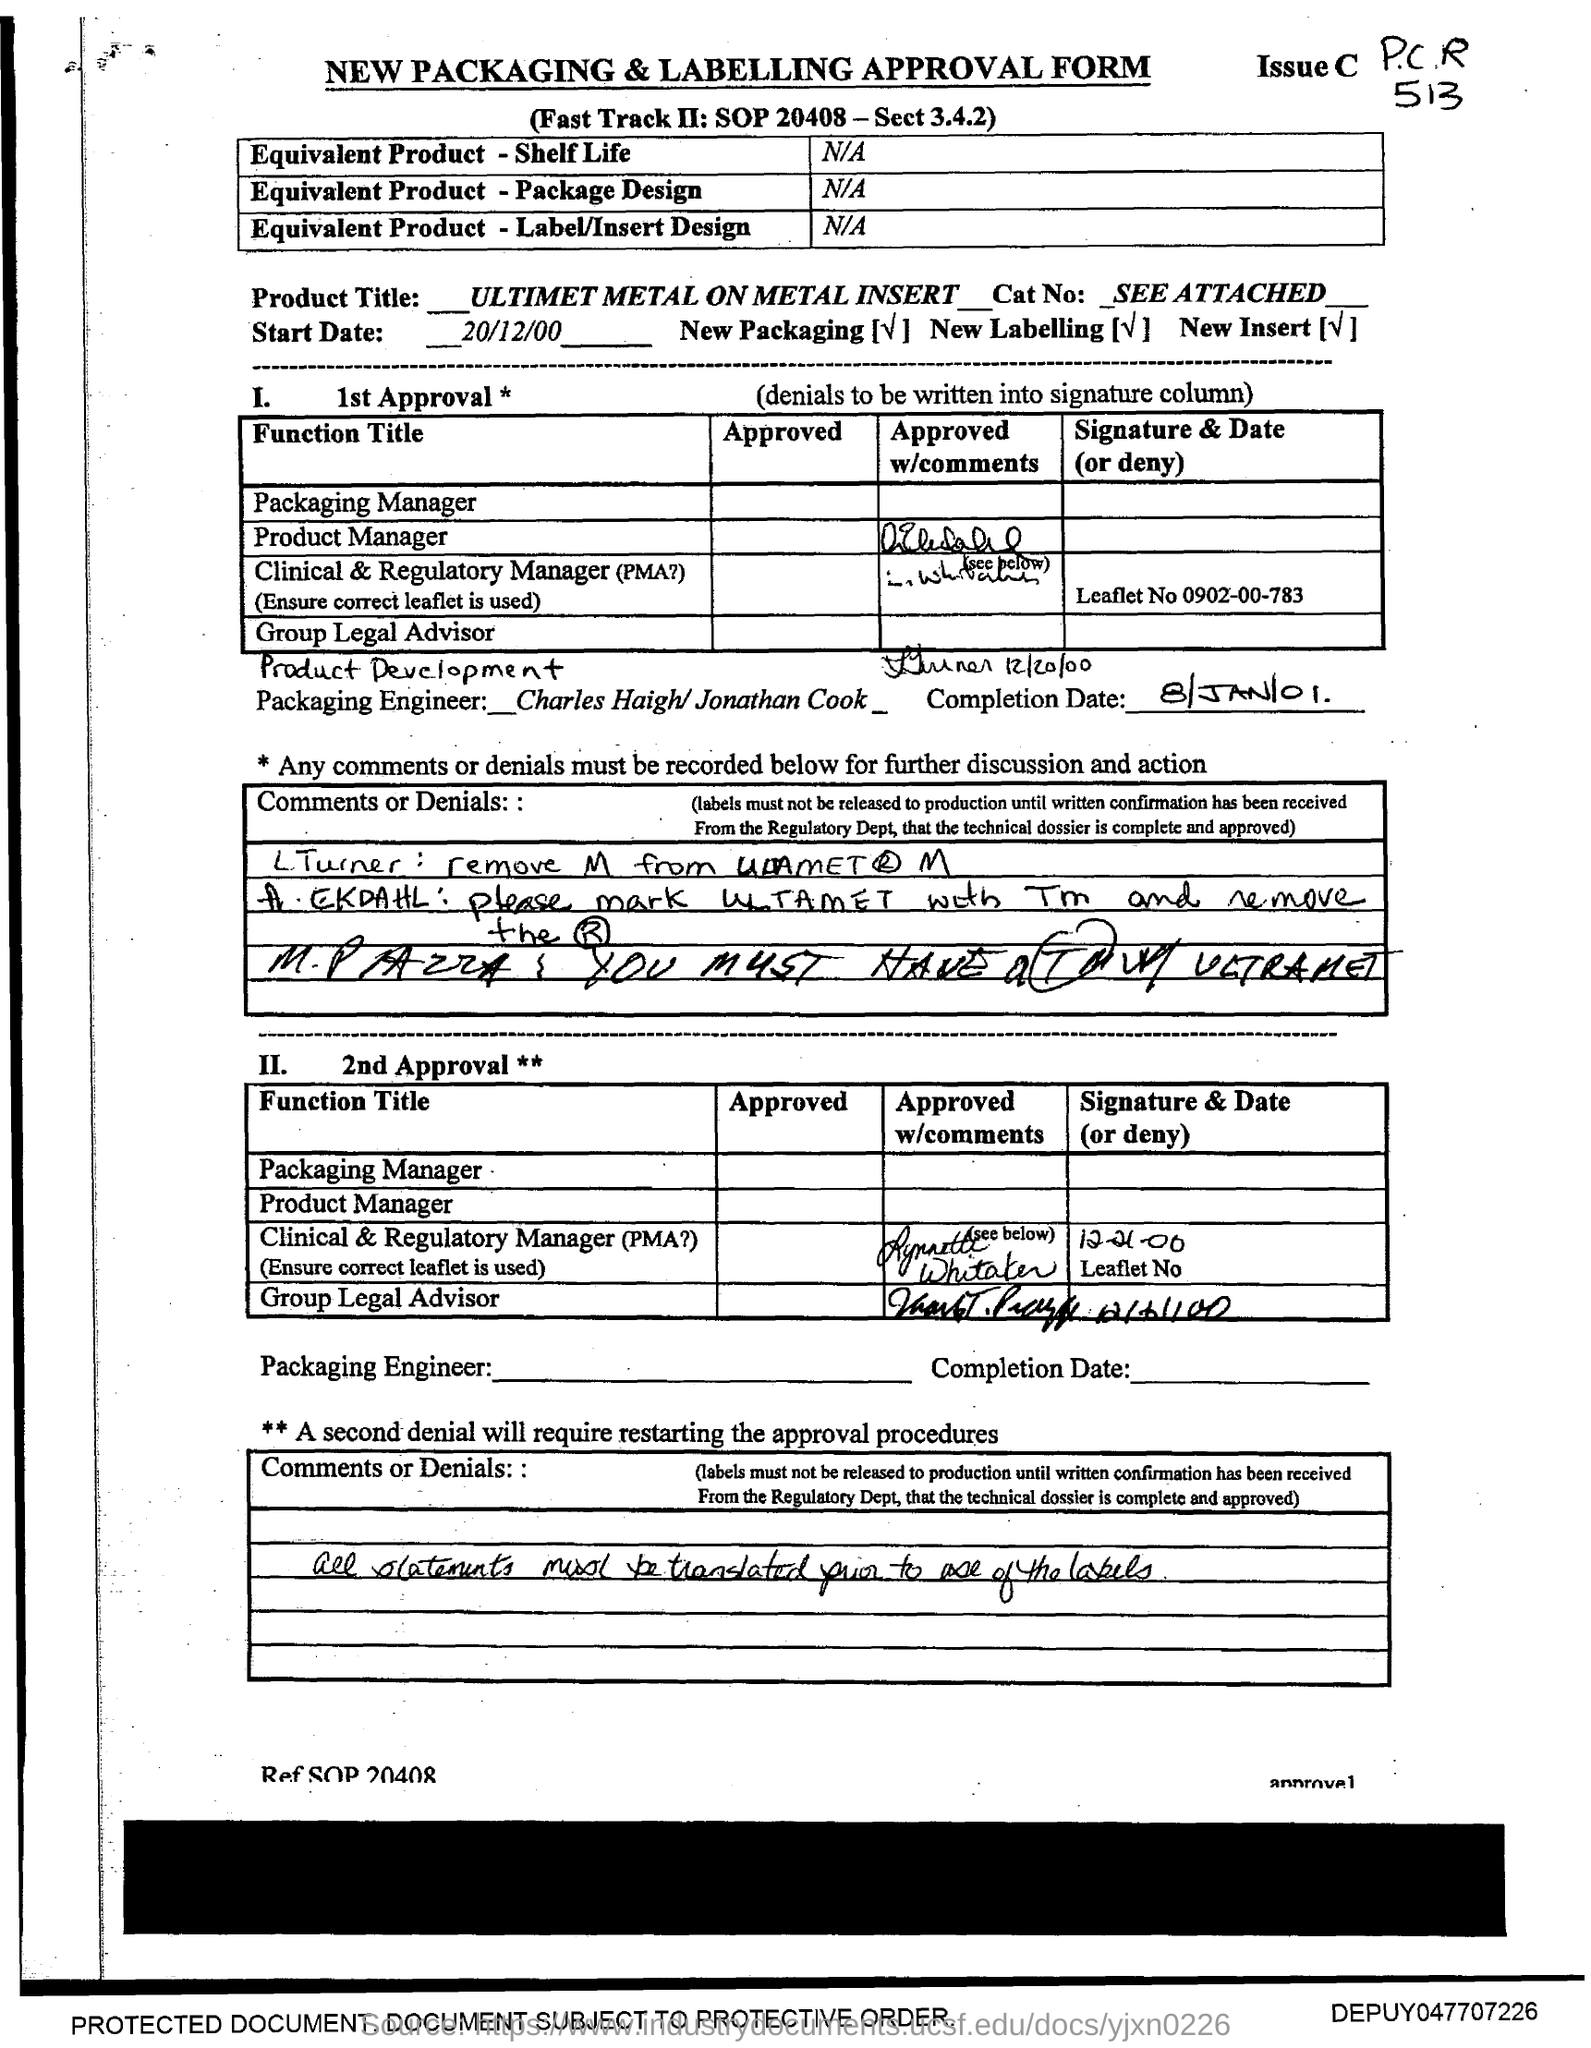Mention a couple of crucial points in this snapshot. The product title mentioned in the form is 'Ultimet Metal On Metal Insert'. The completion date, as provided in the form, is 8/JAN/01. The start date provided in the form is 20/12/00. 